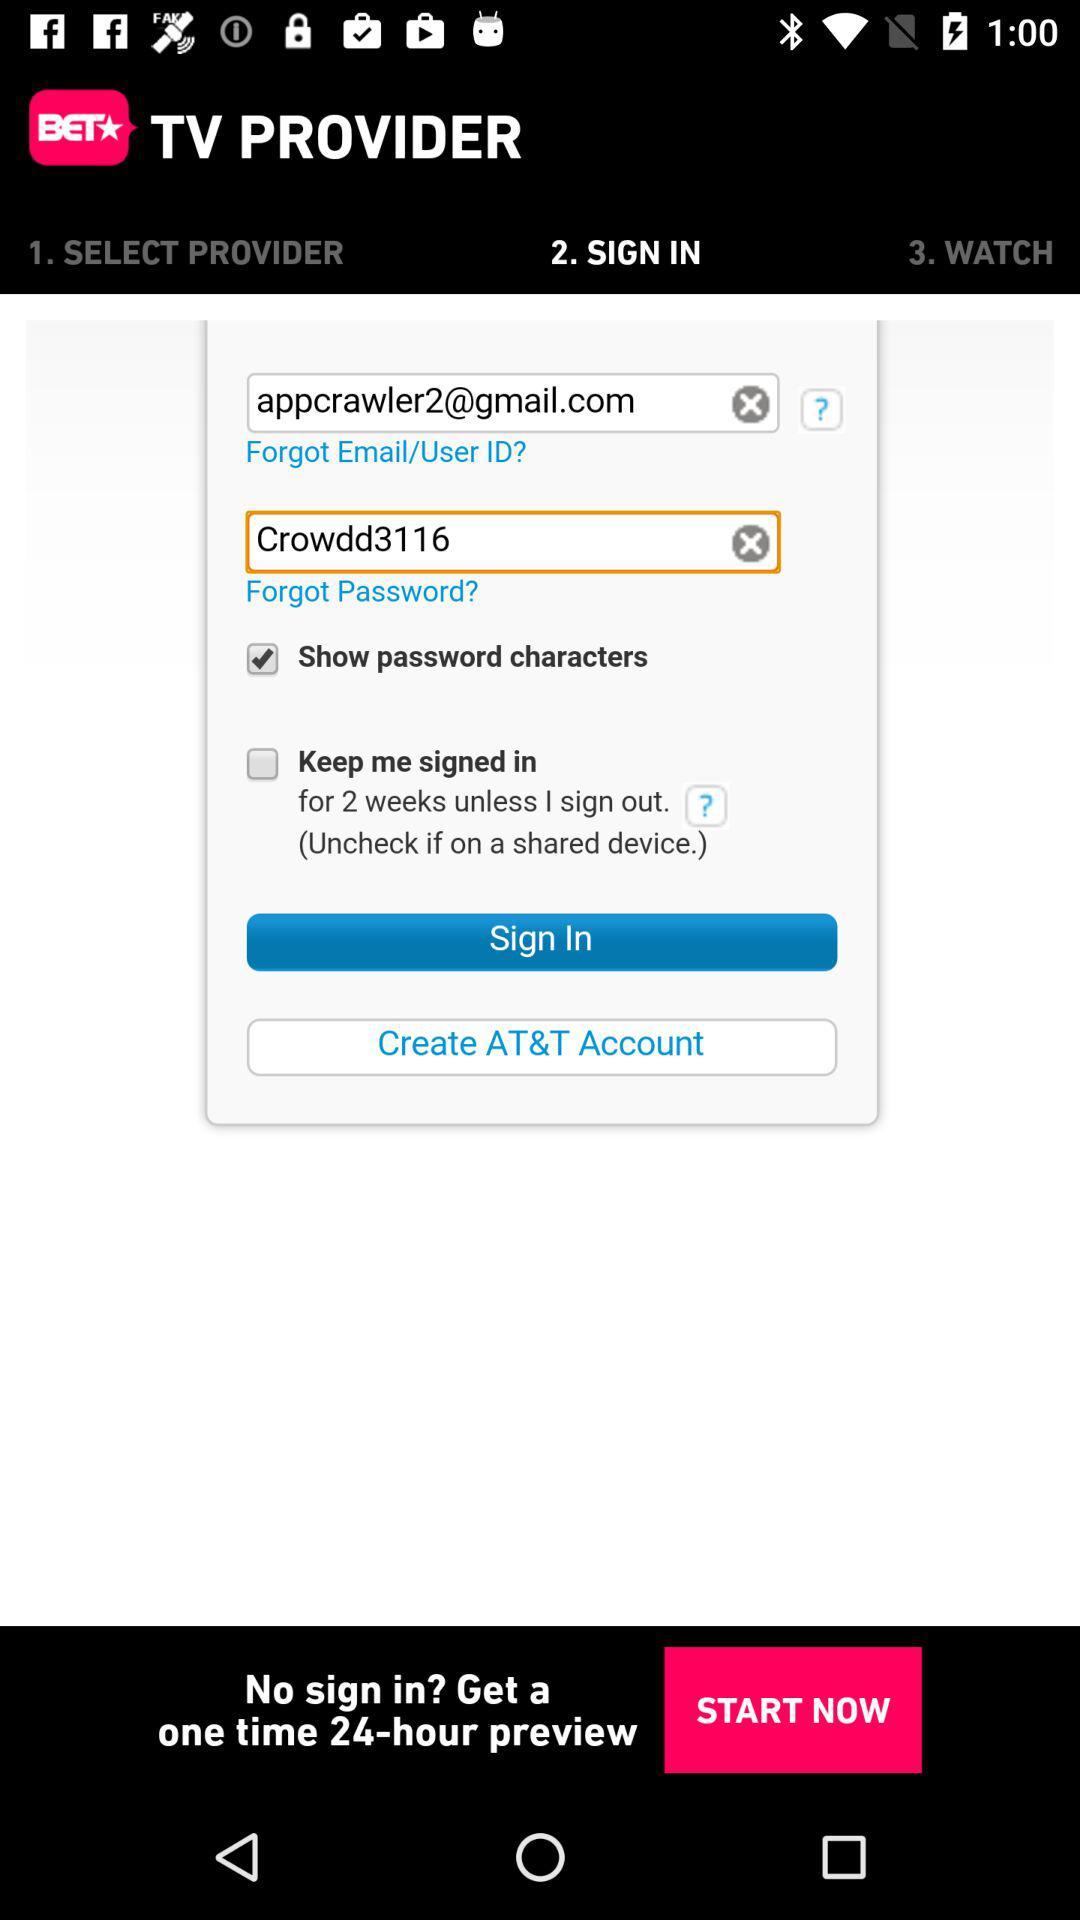What is the status of "Show password characters"? The status of "Show password characters" is "on". 